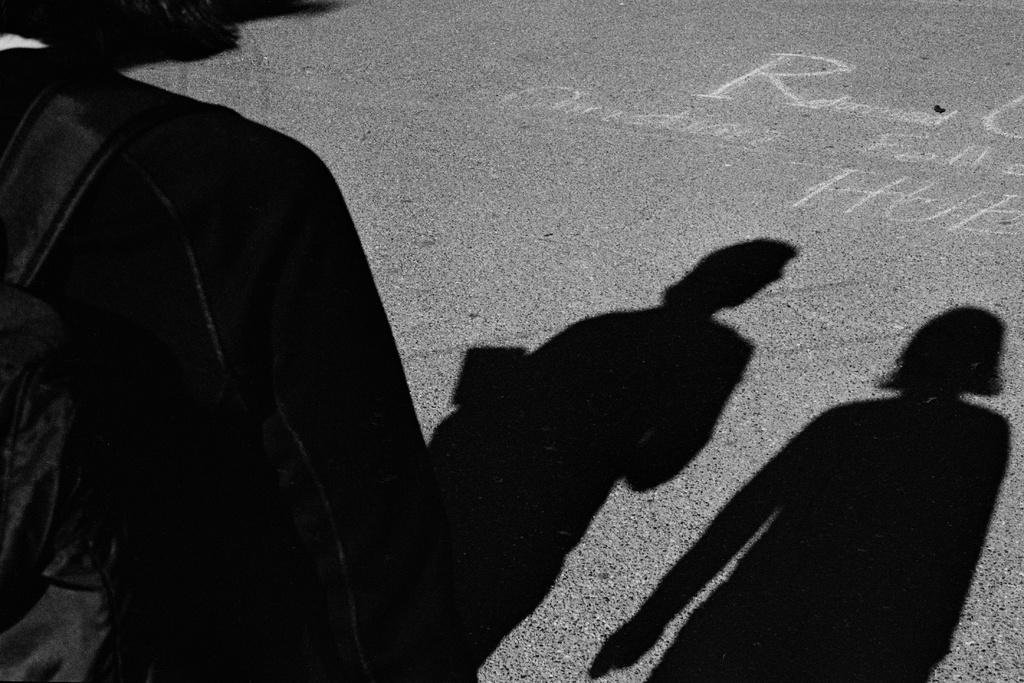What can be seen on the road in the image? There is a person's shadow visible on the road. What is the person wearing in the image? The person is wearing a black color jacket. Is there anything attached to the jacket? Yes, there is a backpack attached to the jacket. What type of cabbage can be seen growing on the side of the road in the image? There is no cabbage visible in the image; it only shows a person's shadow on the road. Can you provide an example of a person wearing a different color jacket in the image? There is no other person wearing a different color jacket in the image; it only shows one person wearing a black jacket. 